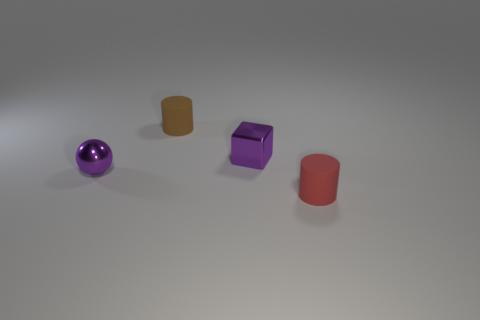Is the number of tiny matte objects that are in front of the tiny block greater than the number of matte cylinders to the left of the brown rubber cylinder?
Provide a short and direct response. Yes. Is the color of the metal ball the same as the metal object that is behind the tiny purple sphere?
Provide a succinct answer. Yes. What material is the brown cylinder that is the same size as the metal ball?
Ensure brevity in your answer.  Rubber. What number of things are either rubber objects or tiny matte cylinders that are in front of the purple sphere?
Offer a terse response. 2. Is the size of the brown cylinder the same as the rubber object that is on the right side of the brown cylinder?
Your answer should be compact. Yes. What number of balls are either tiny purple things or tiny objects?
Provide a short and direct response. 1. What number of small cylinders are both on the left side of the metallic block and in front of the brown matte thing?
Offer a very short reply. 0. What shape is the small object that is on the left side of the brown matte cylinder?
Offer a very short reply. Sphere. Is the material of the sphere the same as the tiny cube?
Offer a terse response. Yes. There is a brown matte thing; how many purple blocks are to the left of it?
Give a very brief answer. 0. 